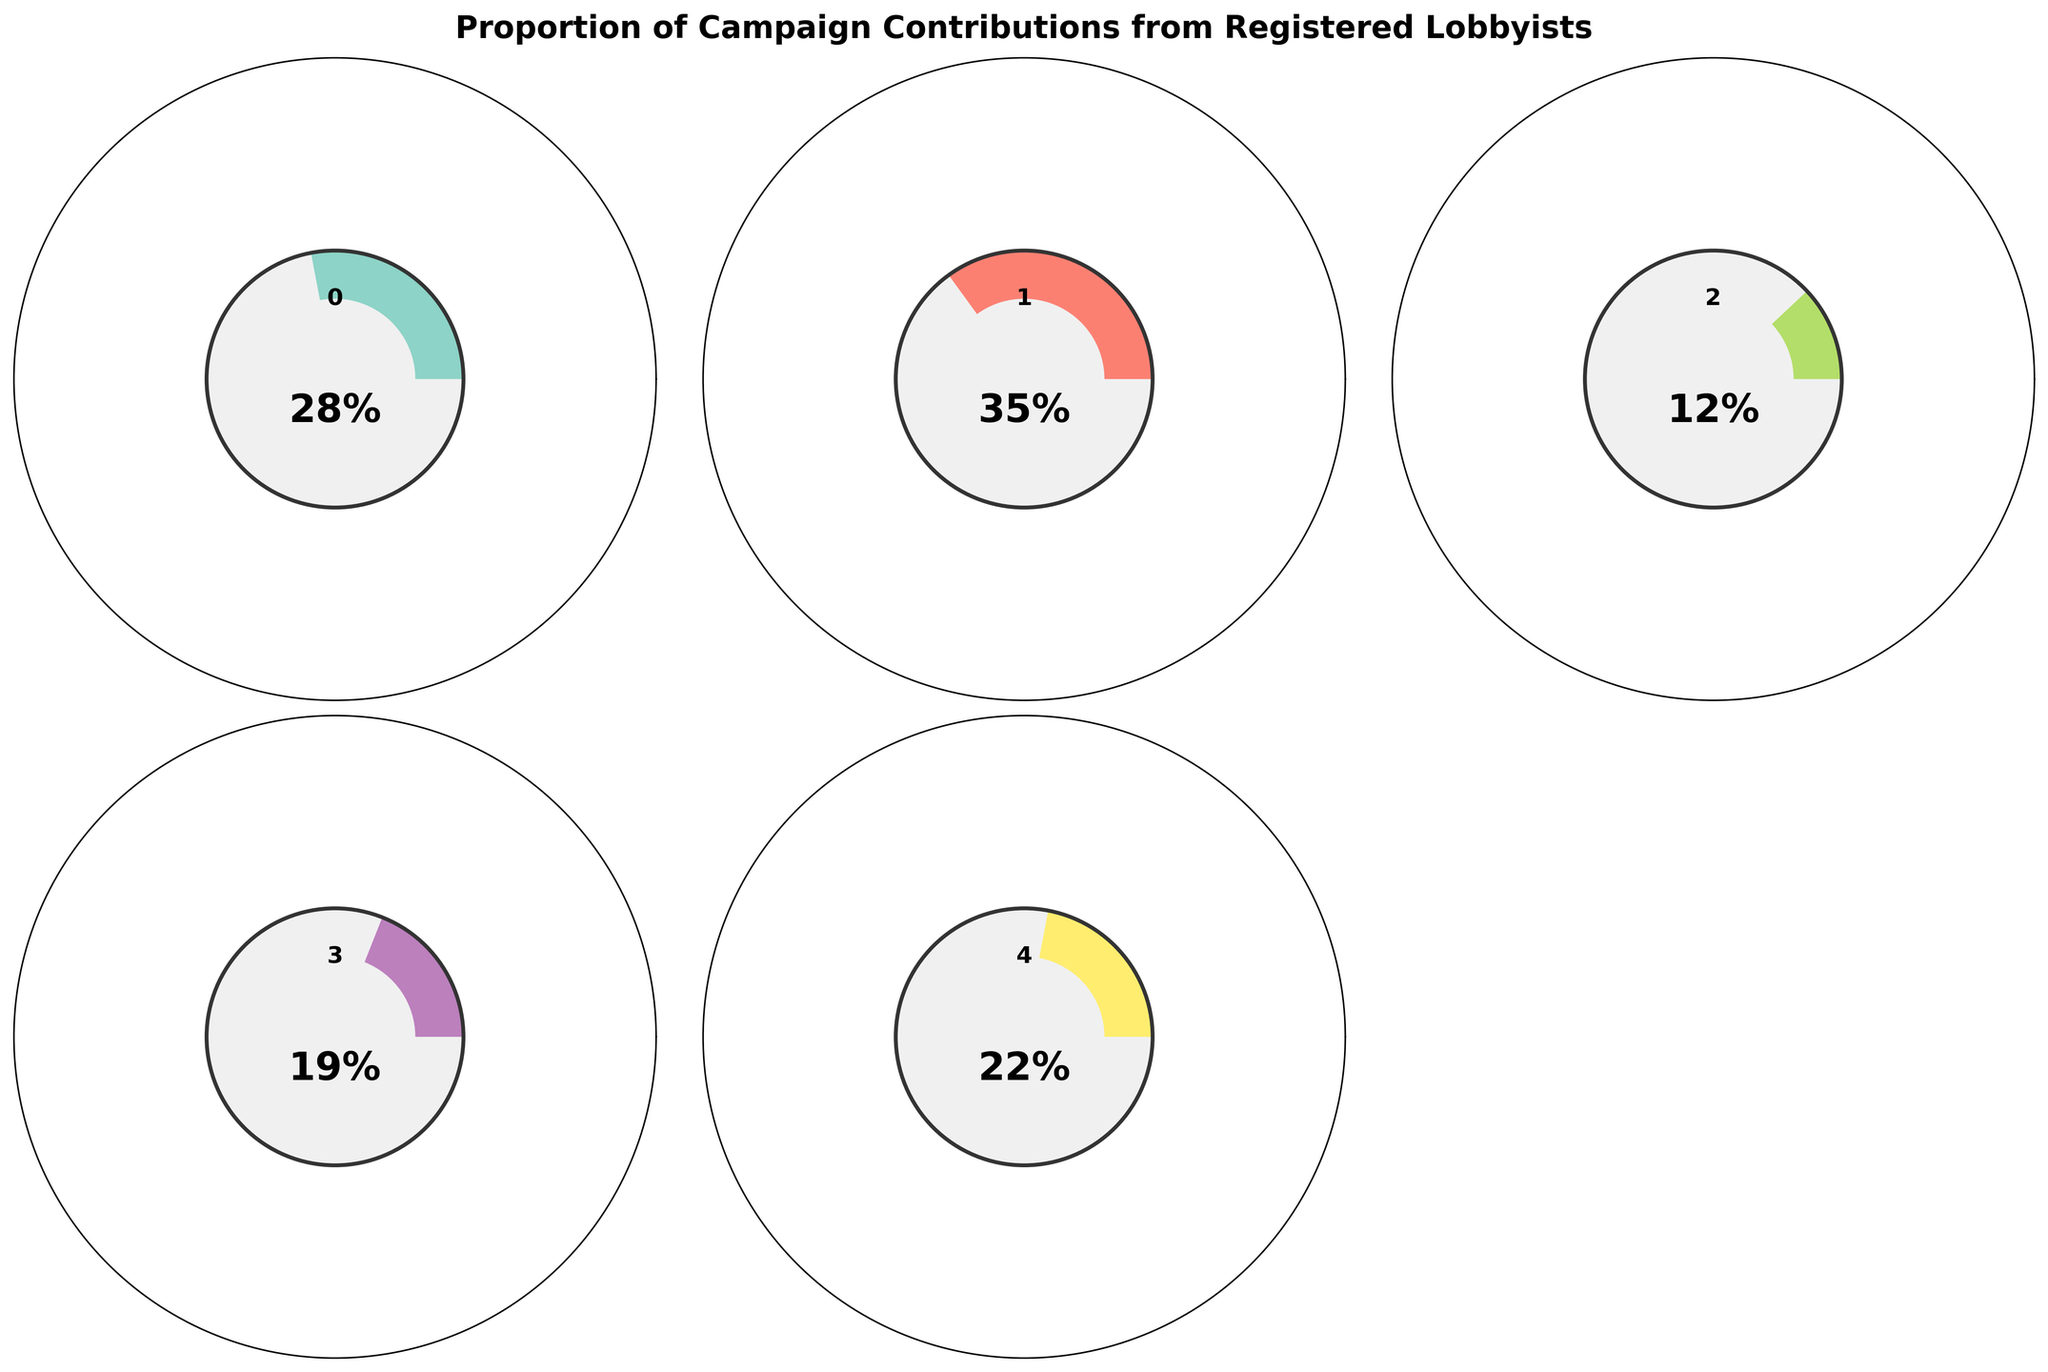what is the title of the figure? The title of the figure is "Proportion of Campaign Contributions from Registered Lobbyists," located at the top of the figure.
Answer: Proportion of Campaign Contributions from Registered Lobbyists How many categories are represented in the figure? The figure contains five categories, one for each party or group of candidates.
Answer: Five Which category has the highest proportion of campaign contributions from registered lobbyists? The Republican Party has the highest proportion, with 0.35 or 35% of contributions.
Answer: Republican Party What is the proportion of campaign contributions from registered lobbyists for the Libertarian Party? The Libertarian Party's proportion is represented on the gauge as 0.19 or 19%.
Answer: 0.19 or 19% Which category has the lowest proportion and what is that proportion? The Green Party has the lowest proportion of contributions from registered lobbyists at 0.12 or 12%.
Answer: Green Party, 0.12 or 12% Is the proportion of campaign contributions from registered lobbyists for Independent Candidates higher or lower than for the Libertarian Party? The proportion for Independent Candidates (0.22 or 22%) is higher than that for the Libertarian Party (0.19 or 19%).
Answer: Higher Which categories have proportions of campaign contributions from registered lobbyists greater than 0.25? The Democratic Party and the Republican Party both have proportions greater than 0.25, at 0.28 and 0.35, respectively.
Answer: Democratic Party, Republican Party What is the difference in proportion between the Republican and Democratic parties? The difference is calculated as 0.35 (Republican) - 0.28 (Democratic) = 0.07 or 7%. So, the Republican Party has a 7% higher proportion of contributions from lobbyists.
Answer: 0.07 or 7% What is the average proportion of campaign contributions from registered lobbyists across all categories? Calculate the average as follows: (0.28 + 0.35 + 0.12 + 0.19 + 0.22) / 5 = 1.16 / 5 = 0.232 or 23.2%. The average proportion across all categories is 23.2%.
Answer: 0.232 or 23.2% What is unique about the visualization method used in the figure? The figure uses gauge charts, which are circular and display proportions with a colored wedge. This method highlights how close each category is to the maximum possible proportion, creating an easy visual comparison.
Answer: Gauge charts Which category is closest to the average proportion of campaign contributions from registered lobbyists? The average proportion is 0.232 or 23.2%, and the Independent Candidates' proportion is 0.22 or 22%, which is closest to the average.
Answer: Independent Candidates 